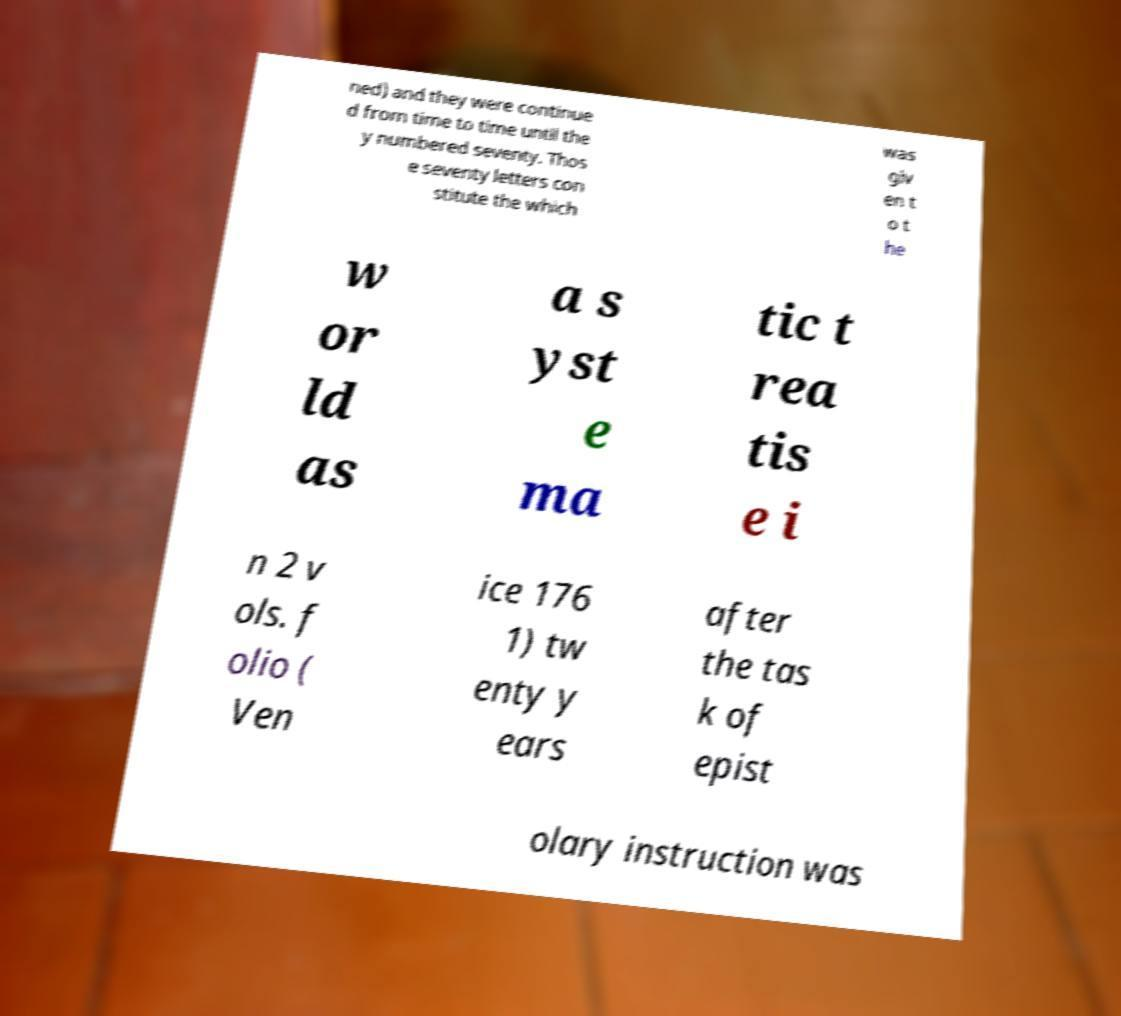For documentation purposes, I need the text within this image transcribed. Could you provide that? ned) and they were continue d from time to time until the y numbered seventy. Thos e seventy letters con stitute the which was giv en t o t he w or ld as a s yst e ma tic t rea tis e i n 2 v ols. f olio ( Ven ice 176 1) tw enty y ears after the tas k of epist olary instruction was 